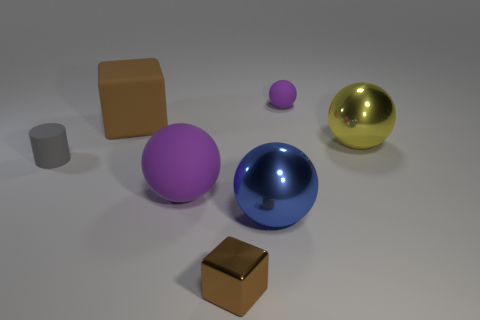The purple rubber object that is in front of the big object that is on the right side of the matte ball that is behind the large brown object is what shape?
Provide a short and direct response. Sphere. There is a purple ball that is in front of the matte ball behind the gray thing; what is its material?
Offer a terse response. Rubber. What is the shape of the small purple object that is made of the same material as the large cube?
Your response must be concise. Sphere. Are there any other things that are the same shape as the large blue metal object?
Provide a succinct answer. Yes. How many small purple matte objects are right of the small metal cube?
Offer a terse response. 1. Are there any large purple rubber things?
Your answer should be very brief. Yes. The small rubber cylinder in front of the big brown rubber object to the left of the purple sphere in front of the yellow metal sphere is what color?
Keep it short and to the point. Gray. Are there any rubber blocks right of the rubber ball in front of the brown matte object?
Ensure brevity in your answer.  No. There is a rubber sphere on the left side of the large blue thing; is it the same color as the object behind the big matte cube?
Your answer should be compact. Yes. How many yellow things are the same size as the blue sphere?
Your response must be concise. 1. 